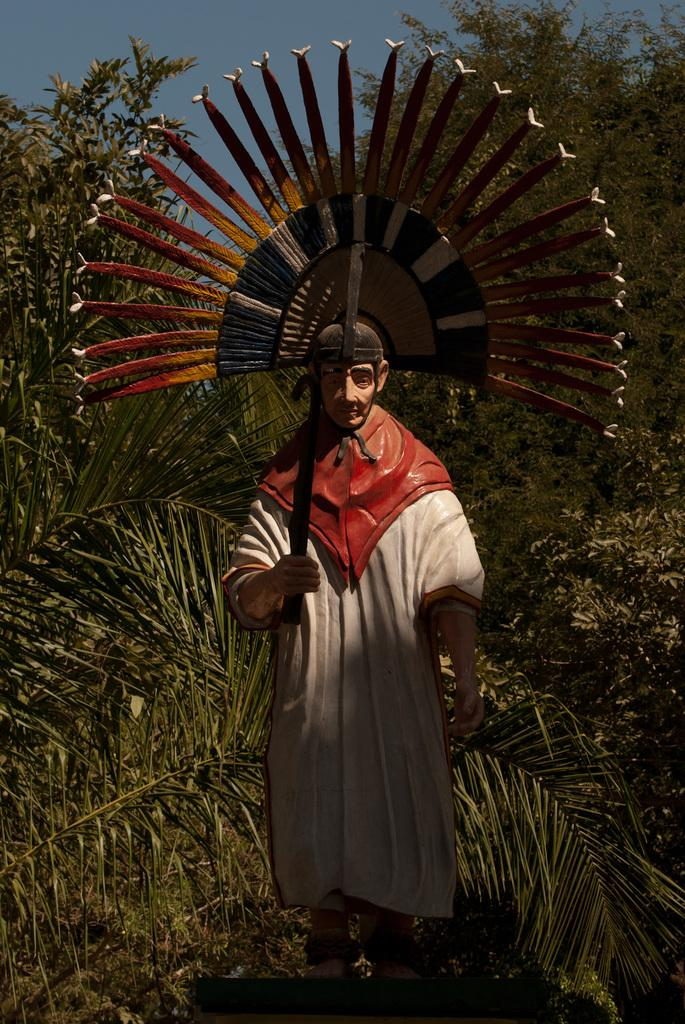What is the main subject of the image? There is a statue of a person standing in the image. What can be seen in the background of the image? There are trees visible in the background of the image. What is visible at the top of the image? The sky is visible at the top of the image. Can you tell me how many monkeys are sitting on the statue in the image? There are no monkeys present in the image; it features a statue of a person. What type of adjustment is being made to the statue in the image? There is no adjustment being made to the statue in the image; it is stationary. 